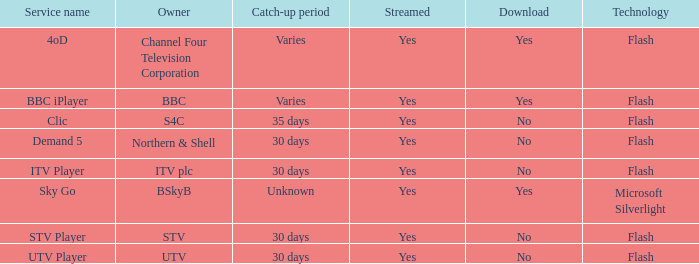What is the Service name of BBC? BBC iPlayer. 